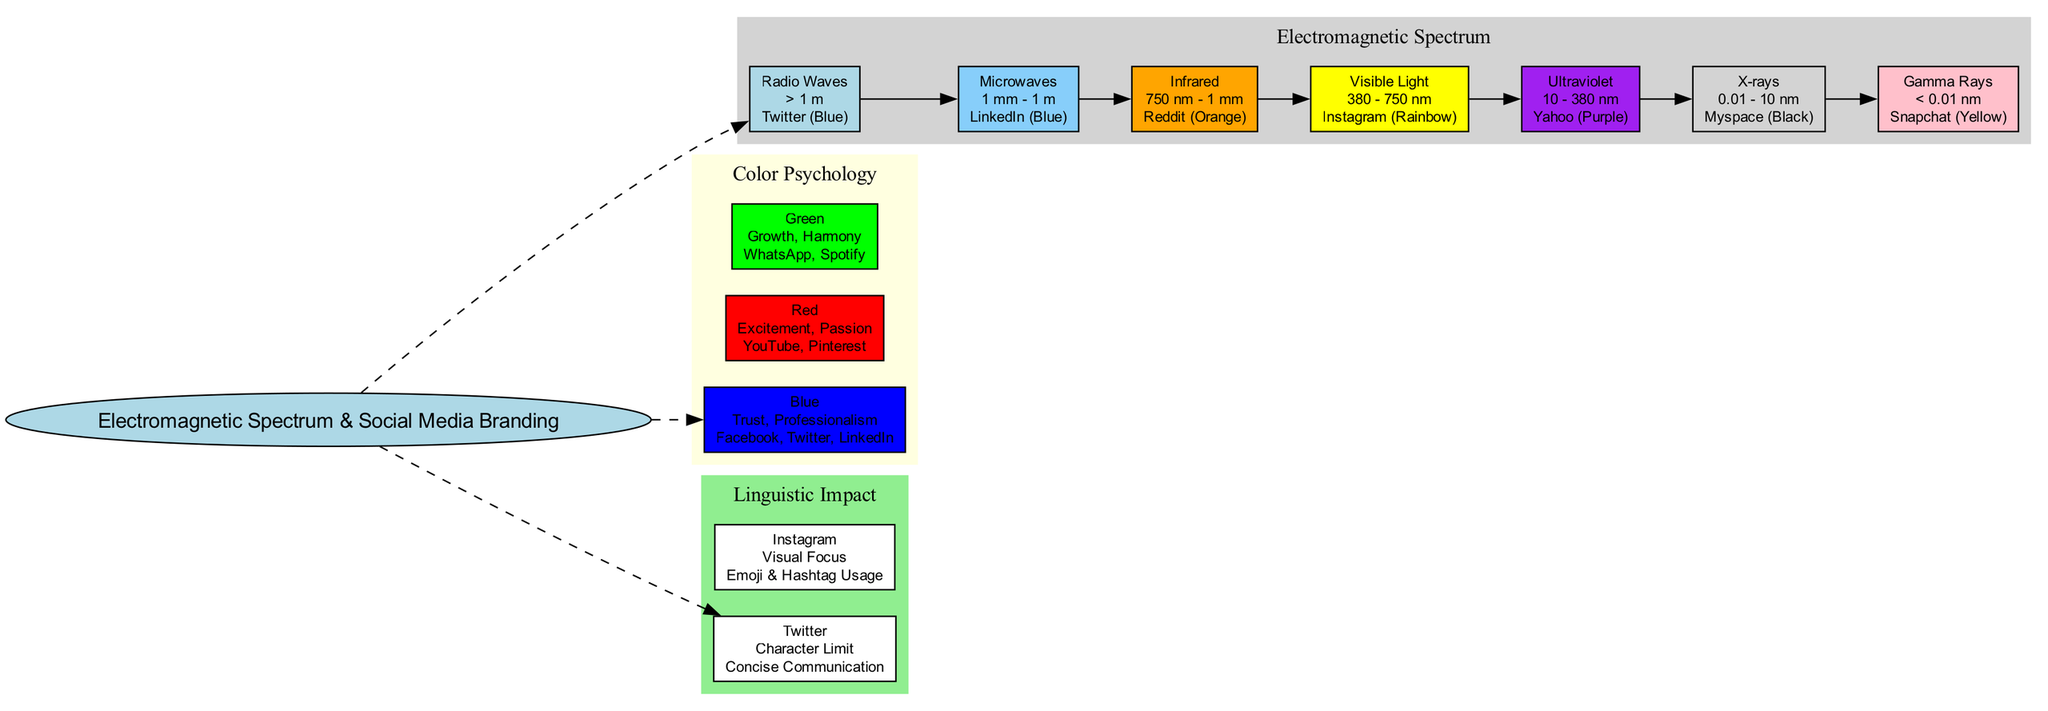What social media example is associated with Infrared? The diagram shows that Infrared is linked to Reddit, indicated in the spectrum bands section.
Answer: Reddit (Orange) How many spectrum bands are there in total? The diagram lists seven spectrum bands, counting each one from Radio Waves through Gamma Rays.
Answer: 7 What color is associated with Ultraviolet in the color psychology section? The diagram specifies that Ultraviolet is associated with the color Purple, as shown in the color psychology cluster.
Answer: Purple Which social media platforms are represented by the color Blue? The diagram indicates that Facebook, Twitter, and LinkedIn are the platforms related to the color Blue in the psychology section.
Answer: Facebook, Twitter, LinkedIn What is the meaning of the color Red according to the diagram? The diagram states that Red represents Excitement and Passion in the color psychology section.
Answer: Excitement, Passion What linguistic feature is linked to Twitter? The diagram highlights that Twitter's linguistic feature is its Character Limit, leading to Concise Communication.
Answer: Character Limit Which electromagnetic spectrum band has the wavelength of 380 - 750 nm? The diagram clearly shows that the band corresponding to that wavelength is Visible Light, located near the center of the spectrum bands.
Answer: Visible Light How does Instagram's feature affect language usage? The diagram points out that Instagram's Visual Focus encourages Emoji & Hashtag Usage, indicating a greater reliance on visual language.
Answer: Emoji & Hashtag Usage Which social media platform is identified with the electromagnetic spectrum band of X-rays? The diagram specifically states that Myspace is associated with the X-rays band, denoting its color scheme as Black.
Answer: Myspace (Black) 